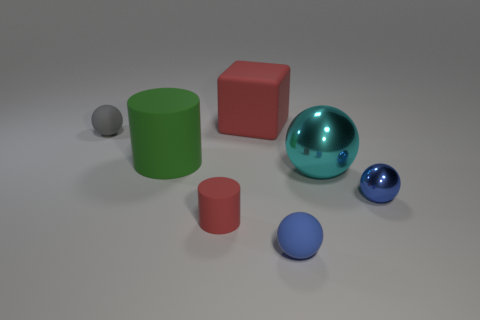Add 2 green rubber things. How many objects exist? 9 Subtract all blocks. How many objects are left? 6 Add 5 large matte objects. How many large matte objects exist? 7 Subtract 0 yellow balls. How many objects are left? 7 Subtract all large red rubber cubes. Subtract all blocks. How many objects are left? 5 Add 7 tiny red rubber objects. How many tiny red rubber objects are left? 8 